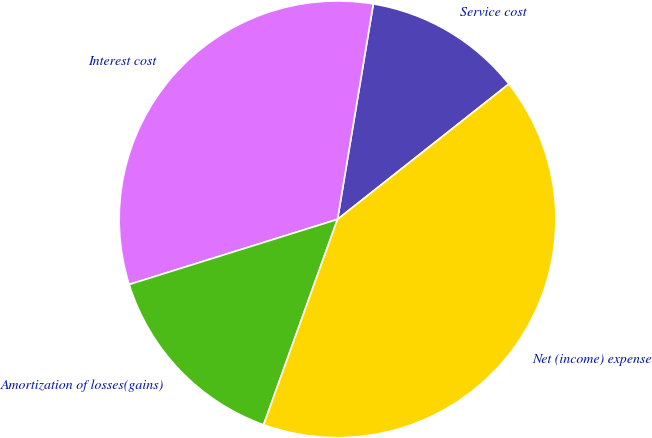Convert chart. <chart><loc_0><loc_0><loc_500><loc_500><pie_chart><fcel>Service cost<fcel>Interest cost<fcel>Amortization of losses(gains)<fcel>Net (income) expense<nl><fcel>11.74%<fcel>32.44%<fcel>14.68%<fcel>41.13%<nl></chart> 